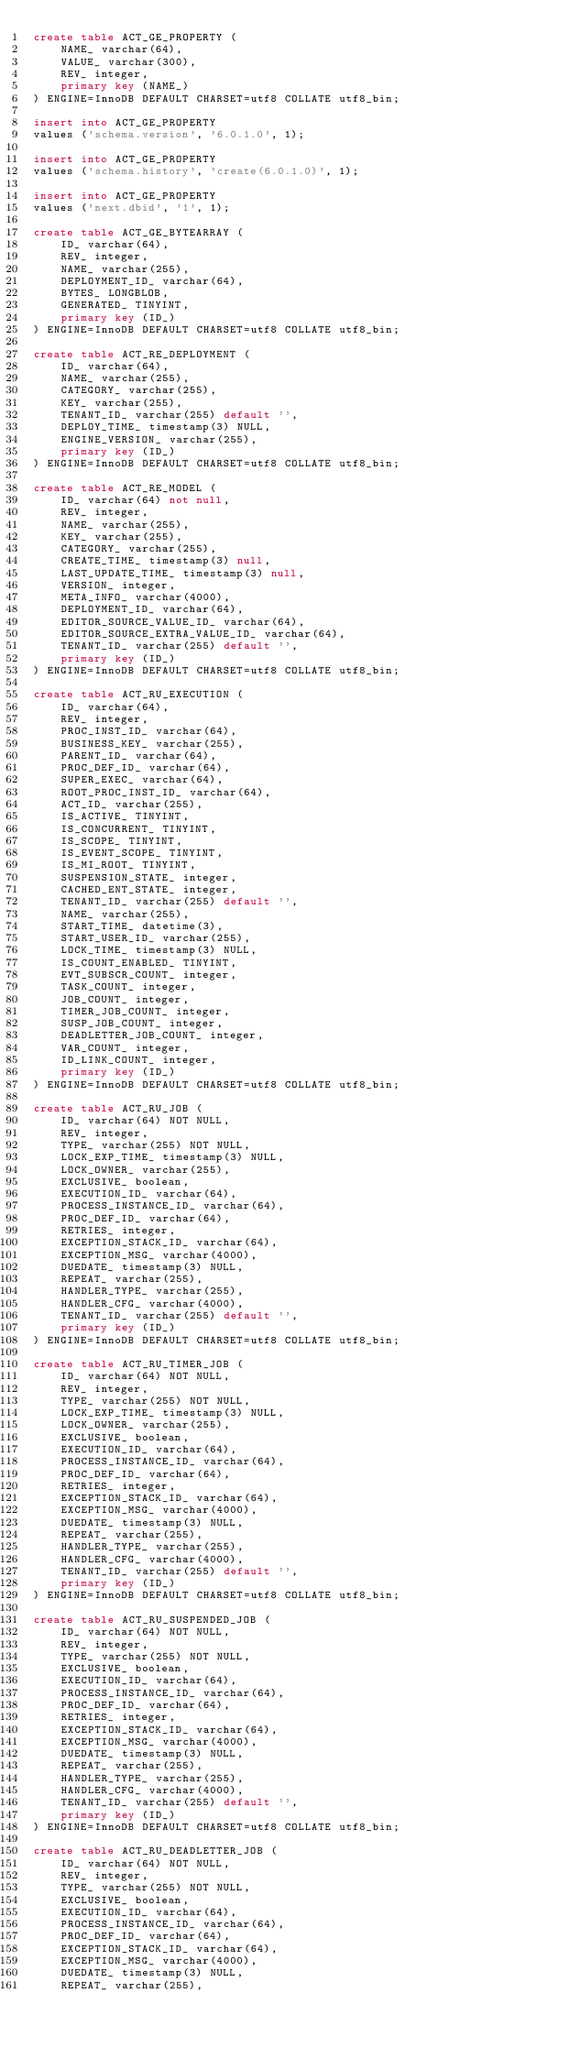<code> <loc_0><loc_0><loc_500><loc_500><_SQL_>create table ACT_GE_PROPERTY (
    NAME_ varchar(64),
    VALUE_ varchar(300),
    REV_ integer,
    primary key (NAME_)
) ENGINE=InnoDB DEFAULT CHARSET=utf8 COLLATE utf8_bin;

insert into ACT_GE_PROPERTY
values ('schema.version', '6.0.1.0', 1);

insert into ACT_GE_PROPERTY
values ('schema.history', 'create(6.0.1.0)', 1);

insert into ACT_GE_PROPERTY
values ('next.dbid', '1', 1);

create table ACT_GE_BYTEARRAY (
    ID_ varchar(64),
    REV_ integer,
    NAME_ varchar(255),
    DEPLOYMENT_ID_ varchar(64),
    BYTES_ LONGBLOB,
    GENERATED_ TINYINT,
    primary key (ID_)
) ENGINE=InnoDB DEFAULT CHARSET=utf8 COLLATE utf8_bin;

create table ACT_RE_DEPLOYMENT (
    ID_ varchar(64),
    NAME_ varchar(255),
    CATEGORY_ varchar(255),
    KEY_ varchar(255),
    TENANT_ID_ varchar(255) default '',
    DEPLOY_TIME_ timestamp(3) NULL,
    ENGINE_VERSION_ varchar(255),
    primary key (ID_)
) ENGINE=InnoDB DEFAULT CHARSET=utf8 COLLATE utf8_bin;

create table ACT_RE_MODEL (
    ID_ varchar(64) not null,
    REV_ integer,
    NAME_ varchar(255),
    KEY_ varchar(255),
    CATEGORY_ varchar(255),
    CREATE_TIME_ timestamp(3) null,
    LAST_UPDATE_TIME_ timestamp(3) null,
    VERSION_ integer,
    META_INFO_ varchar(4000),
    DEPLOYMENT_ID_ varchar(64),
    EDITOR_SOURCE_VALUE_ID_ varchar(64),
    EDITOR_SOURCE_EXTRA_VALUE_ID_ varchar(64),
    TENANT_ID_ varchar(255) default '',
    primary key (ID_)
) ENGINE=InnoDB DEFAULT CHARSET=utf8 COLLATE utf8_bin;

create table ACT_RU_EXECUTION (
    ID_ varchar(64),
    REV_ integer,
    PROC_INST_ID_ varchar(64),
    BUSINESS_KEY_ varchar(255),
    PARENT_ID_ varchar(64),
    PROC_DEF_ID_ varchar(64),
    SUPER_EXEC_ varchar(64),
    ROOT_PROC_INST_ID_ varchar(64),
    ACT_ID_ varchar(255),
    IS_ACTIVE_ TINYINT,
    IS_CONCURRENT_ TINYINT,
    IS_SCOPE_ TINYINT,
    IS_EVENT_SCOPE_ TINYINT,
    IS_MI_ROOT_ TINYINT,
    SUSPENSION_STATE_ integer,
    CACHED_ENT_STATE_ integer,
    TENANT_ID_ varchar(255) default '',
    NAME_ varchar(255),
    START_TIME_ datetime(3),
    START_USER_ID_ varchar(255),
    LOCK_TIME_ timestamp(3) NULL,
    IS_COUNT_ENABLED_ TINYINT,
    EVT_SUBSCR_COUNT_ integer, 
    TASK_COUNT_ integer, 
    JOB_COUNT_ integer, 
    TIMER_JOB_COUNT_ integer,
    SUSP_JOB_COUNT_ integer,
    DEADLETTER_JOB_COUNT_ integer,
    VAR_COUNT_ integer, 
    ID_LINK_COUNT_ integer,
    primary key (ID_)
) ENGINE=InnoDB DEFAULT CHARSET=utf8 COLLATE utf8_bin;

create table ACT_RU_JOB (
    ID_ varchar(64) NOT NULL,
    REV_ integer,
    TYPE_ varchar(255) NOT NULL,
    LOCK_EXP_TIME_ timestamp(3) NULL,
    LOCK_OWNER_ varchar(255),
    EXCLUSIVE_ boolean,
    EXECUTION_ID_ varchar(64),
    PROCESS_INSTANCE_ID_ varchar(64),
    PROC_DEF_ID_ varchar(64),
    RETRIES_ integer,
    EXCEPTION_STACK_ID_ varchar(64),
    EXCEPTION_MSG_ varchar(4000),
    DUEDATE_ timestamp(3) NULL,
    REPEAT_ varchar(255),
    HANDLER_TYPE_ varchar(255),
    HANDLER_CFG_ varchar(4000),
    TENANT_ID_ varchar(255) default '',
    primary key (ID_)
) ENGINE=InnoDB DEFAULT CHARSET=utf8 COLLATE utf8_bin;

create table ACT_RU_TIMER_JOB (
    ID_ varchar(64) NOT NULL,
    REV_ integer,
    TYPE_ varchar(255) NOT NULL,
    LOCK_EXP_TIME_ timestamp(3) NULL,
    LOCK_OWNER_ varchar(255),
    EXCLUSIVE_ boolean,
    EXECUTION_ID_ varchar(64),
    PROCESS_INSTANCE_ID_ varchar(64),
    PROC_DEF_ID_ varchar(64),
    RETRIES_ integer,
    EXCEPTION_STACK_ID_ varchar(64),
    EXCEPTION_MSG_ varchar(4000),
    DUEDATE_ timestamp(3) NULL,
    REPEAT_ varchar(255),
    HANDLER_TYPE_ varchar(255),
    HANDLER_CFG_ varchar(4000),
    TENANT_ID_ varchar(255) default '',
    primary key (ID_)
) ENGINE=InnoDB DEFAULT CHARSET=utf8 COLLATE utf8_bin;

create table ACT_RU_SUSPENDED_JOB (
    ID_ varchar(64) NOT NULL,
    REV_ integer,
    TYPE_ varchar(255) NOT NULL,
    EXCLUSIVE_ boolean,
    EXECUTION_ID_ varchar(64),
    PROCESS_INSTANCE_ID_ varchar(64),
    PROC_DEF_ID_ varchar(64),
    RETRIES_ integer,
    EXCEPTION_STACK_ID_ varchar(64),
    EXCEPTION_MSG_ varchar(4000),
    DUEDATE_ timestamp(3) NULL,
    REPEAT_ varchar(255),
    HANDLER_TYPE_ varchar(255),
    HANDLER_CFG_ varchar(4000),
    TENANT_ID_ varchar(255) default '',
    primary key (ID_)
) ENGINE=InnoDB DEFAULT CHARSET=utf8 COLLATE utf8_bin;

create table ACT_RU_DEADLETTER_JOB (
    ID_ varchar(64) NOT NULL,
    REV_ integer,
    TYPE_ varchar(255) NOT NULL,
    EXCLUSIVE_ boolean,
    EXECUTION_ID_ varchar(64),
    PROCESS_INSTANCE_ID_ varchar(64),
    PROC_DEF_ID_ varchar(64),
    EXCEPTION_STACK_ID_ varchar(64),
    EXCEPTION_MSG_ varchar(4000),
    DUEDATE_ timestamp(3) NULL,
    REPEAT_ varchar(255),</code> 